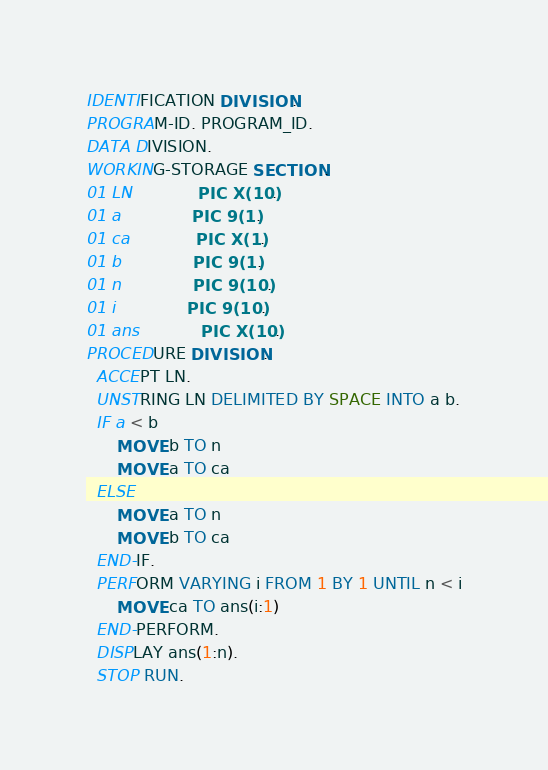<code> <loc_0><loc_0><loc_500><loc_500><_COBOL_>IDENTIFICATION DIVISION.
PROGRAM-ID. PROGRAM_ID.
DATA DIVISION.
WORKING-STORAGE SECTION.
01 LN             PIC X(10).
01 a              PIC 9(1).
01 ca             PIC X(1).
01 b              PIC 9(1).
01 n              PIC 9(10).
01 i              PIC 9(10).
01 ans            PIC X(10).
PROCEDURE DIVISION.
  ACCEPT LN.
  UNSTRING LN DELIMITED BY SPACE INTO a b.
  IF a < b
      MOVE b TO n
      MOVE a TO ca
  ELSE
      MOVE a TO n
      MOVE b TO ca
  END-IF.
  PERFORM VARYING i FROM 1 BY 1 UNTIL n < i
      MOVE ca TO ans(i:1)
  END-PERFORM.
  DISPLAY ans(1:n).
  STOP RUN.
</code> 